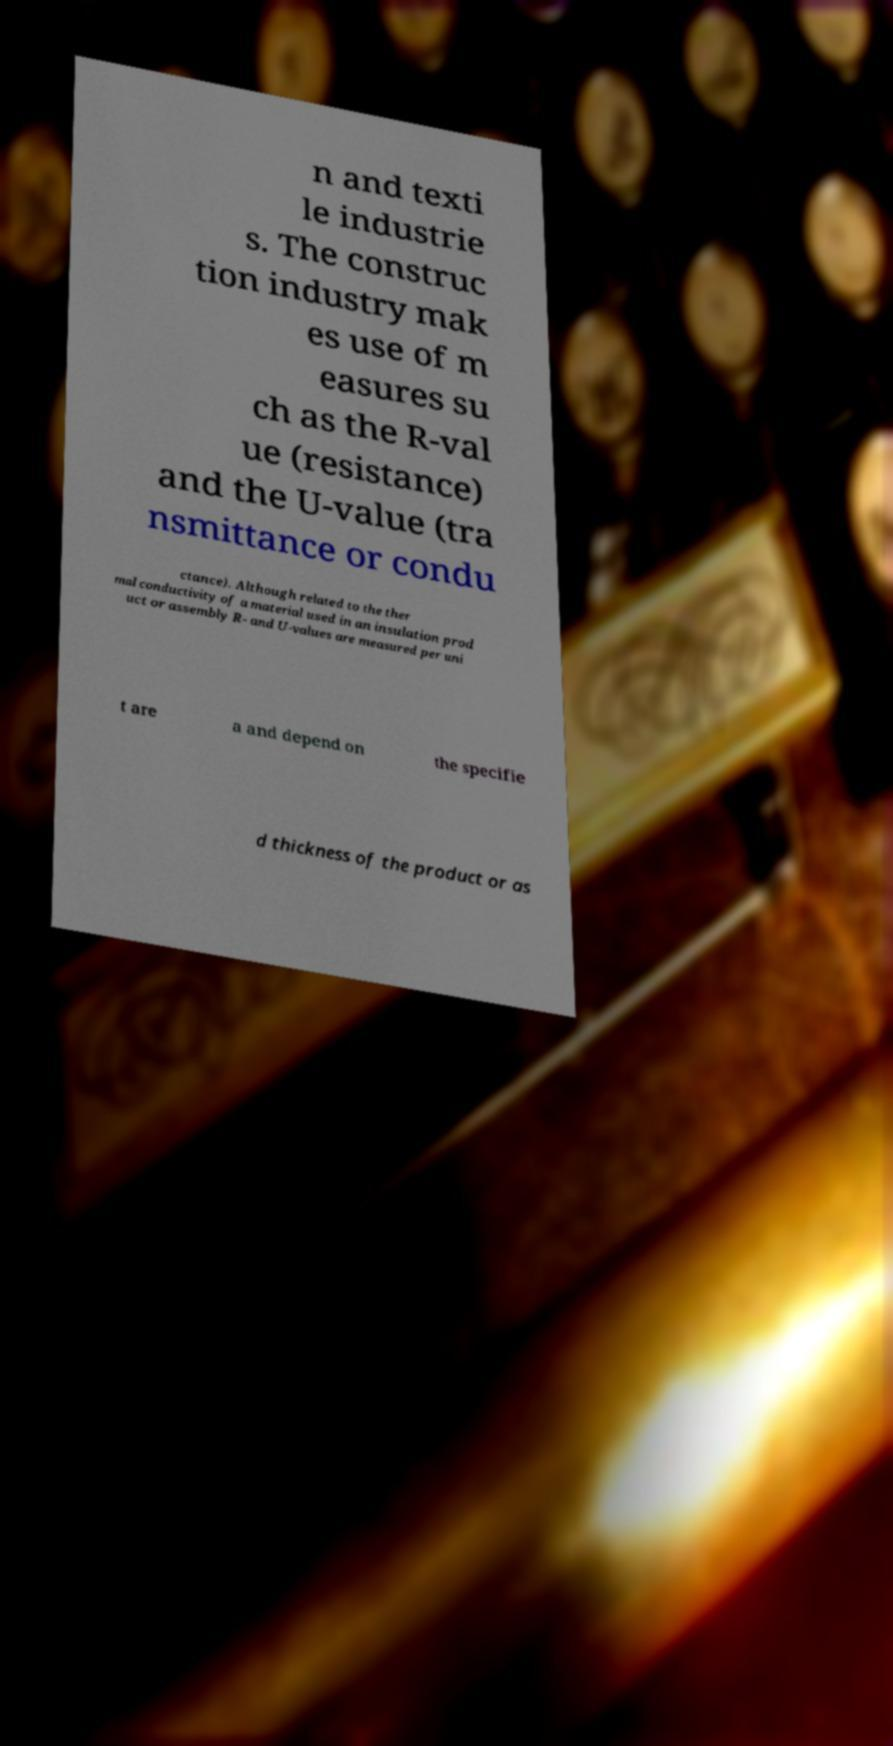Could you extract and type out the text from this image? n and texti le industrie s. The construc tion industry mak es use of m easures su ch as the R-val ue (resistance) and the U-value (tra nsmittance or condu ctance). Although related to the ther mal conductivity of a material used in an insulation prod uct or assembly R- and U-values are measured per uni t are a and depend on the specifie d thickness of the product or as 